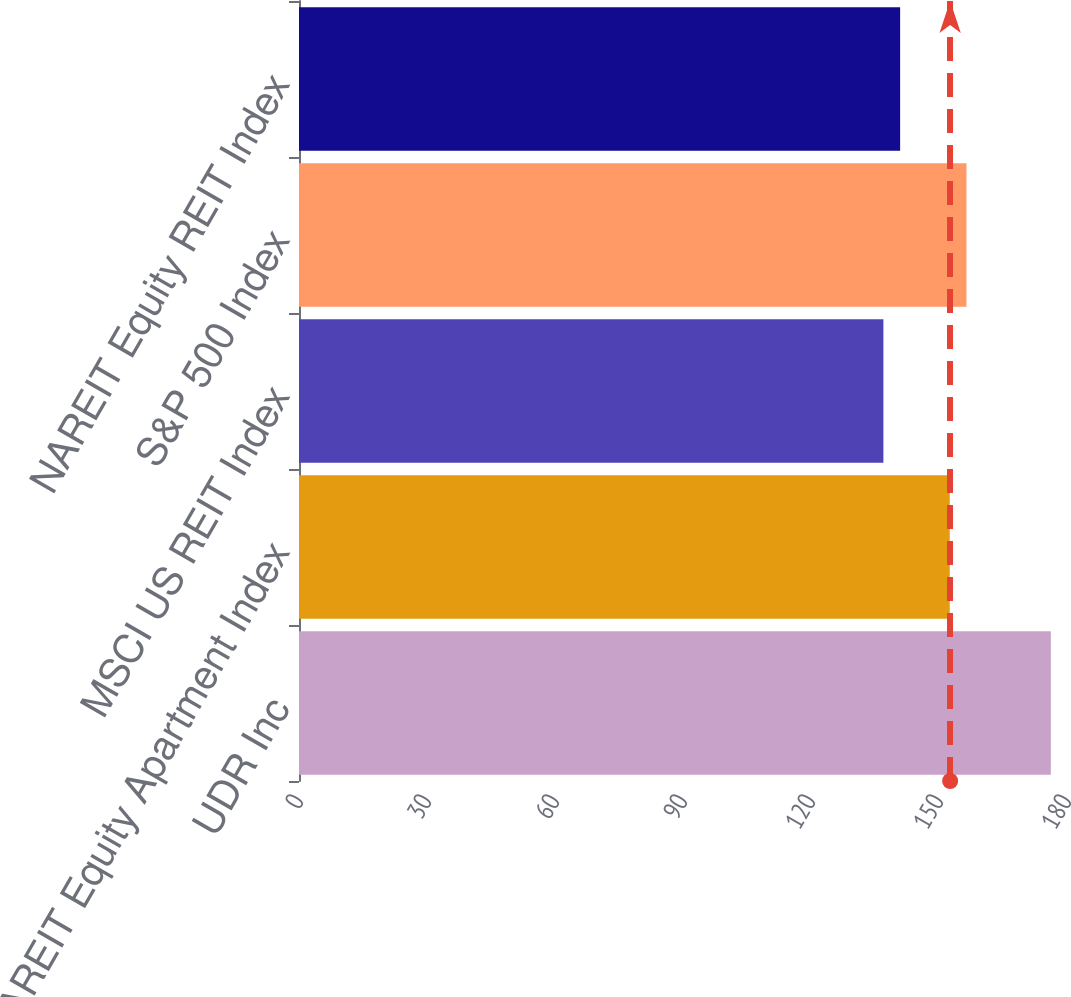<chart> <loc_0><loc_0><loc_500><loc_500><bar_chart><fcel>UDR Inc<fcel>NAREIT Equity Apartment Index<fcel>MSCI US REIT Index<fcel>S&P 500 Index<fcel>NAREIT Equity REIT Index<nl><fcel>176.21<fcel>152.52<fcel>136.97<fcel>156.44<fcel>140.89<nl></chart> 